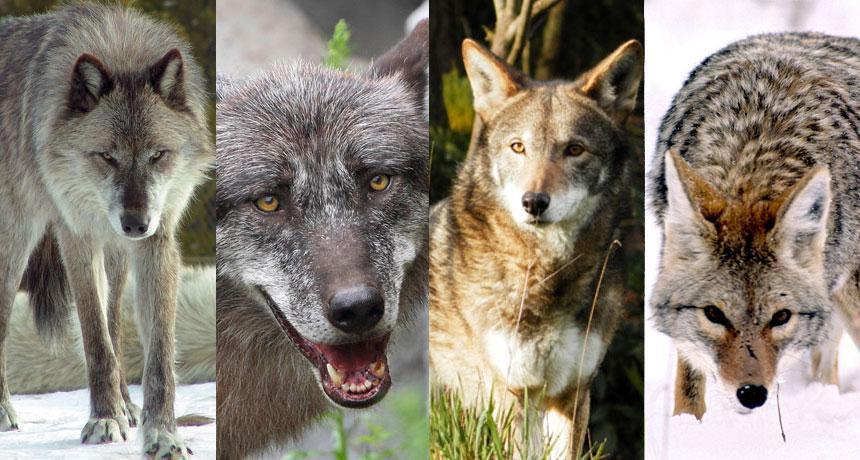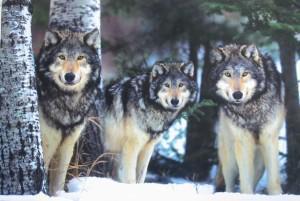The first image is the image on the left, the second image is the image on the right. Evaluate the accuracy of this statement regarding the images: "There are at least six wolves.". Is it true? Answer yes or no. Yes. 